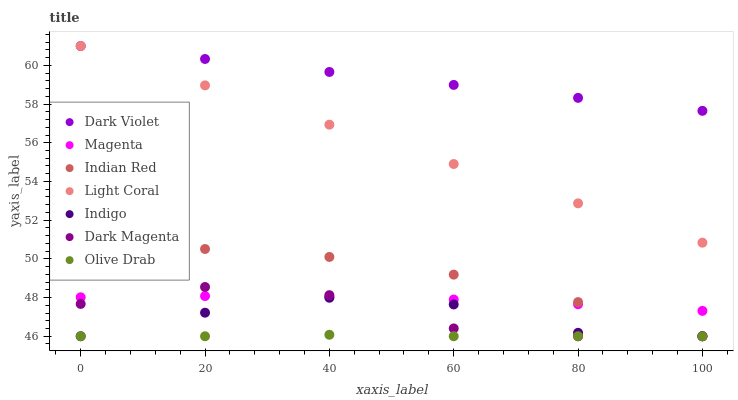Does Olive Drab have the minimum area under the curve?
Answer yes or no. Yes. Does Dark Violet have the maximum area under the curve?
Answer yes or no. Yes. Does Dark Magenta have the minimum area under the curve?
Answer yes or no. No. Does Dark Magenta have the maximum area under the curve?
Answer yes or no. No. Is Light Coral the smoothest?
Answer yes or no. Yes. Is Dark Magenta the roughest?
Answer yes or no. Yes. Is Dark Violet the smoothest?
Answer yes or no. No. Is Dark Violet the roughest?
Answer yes or no. No. Does Indigo have the lowest value?
Answer yes or no. Yes. Does Dark Violet have the lowest value?
Answer yes or no. No. Does Light Coral have the highest value?
Answer yes or no. Yes. Does Dark Magenta have the highest value?
Answer yes or no. No. Is Olive Drab less than Magenta?
Answer yes or no. Yes. Is Magenta greater than Indigo?
Answer yes or no. Yes. Does Dark Magenta intersect Indian Red?
Answer yes or no. Yes. Is Dark Magenta less than Indian Red?
Answer yes or no. No. Is Dark Magenta greater than Indian Red?
Answer yes or no. No. Does Olive Drab intersect Magenta?
Answer yes or no. No. 